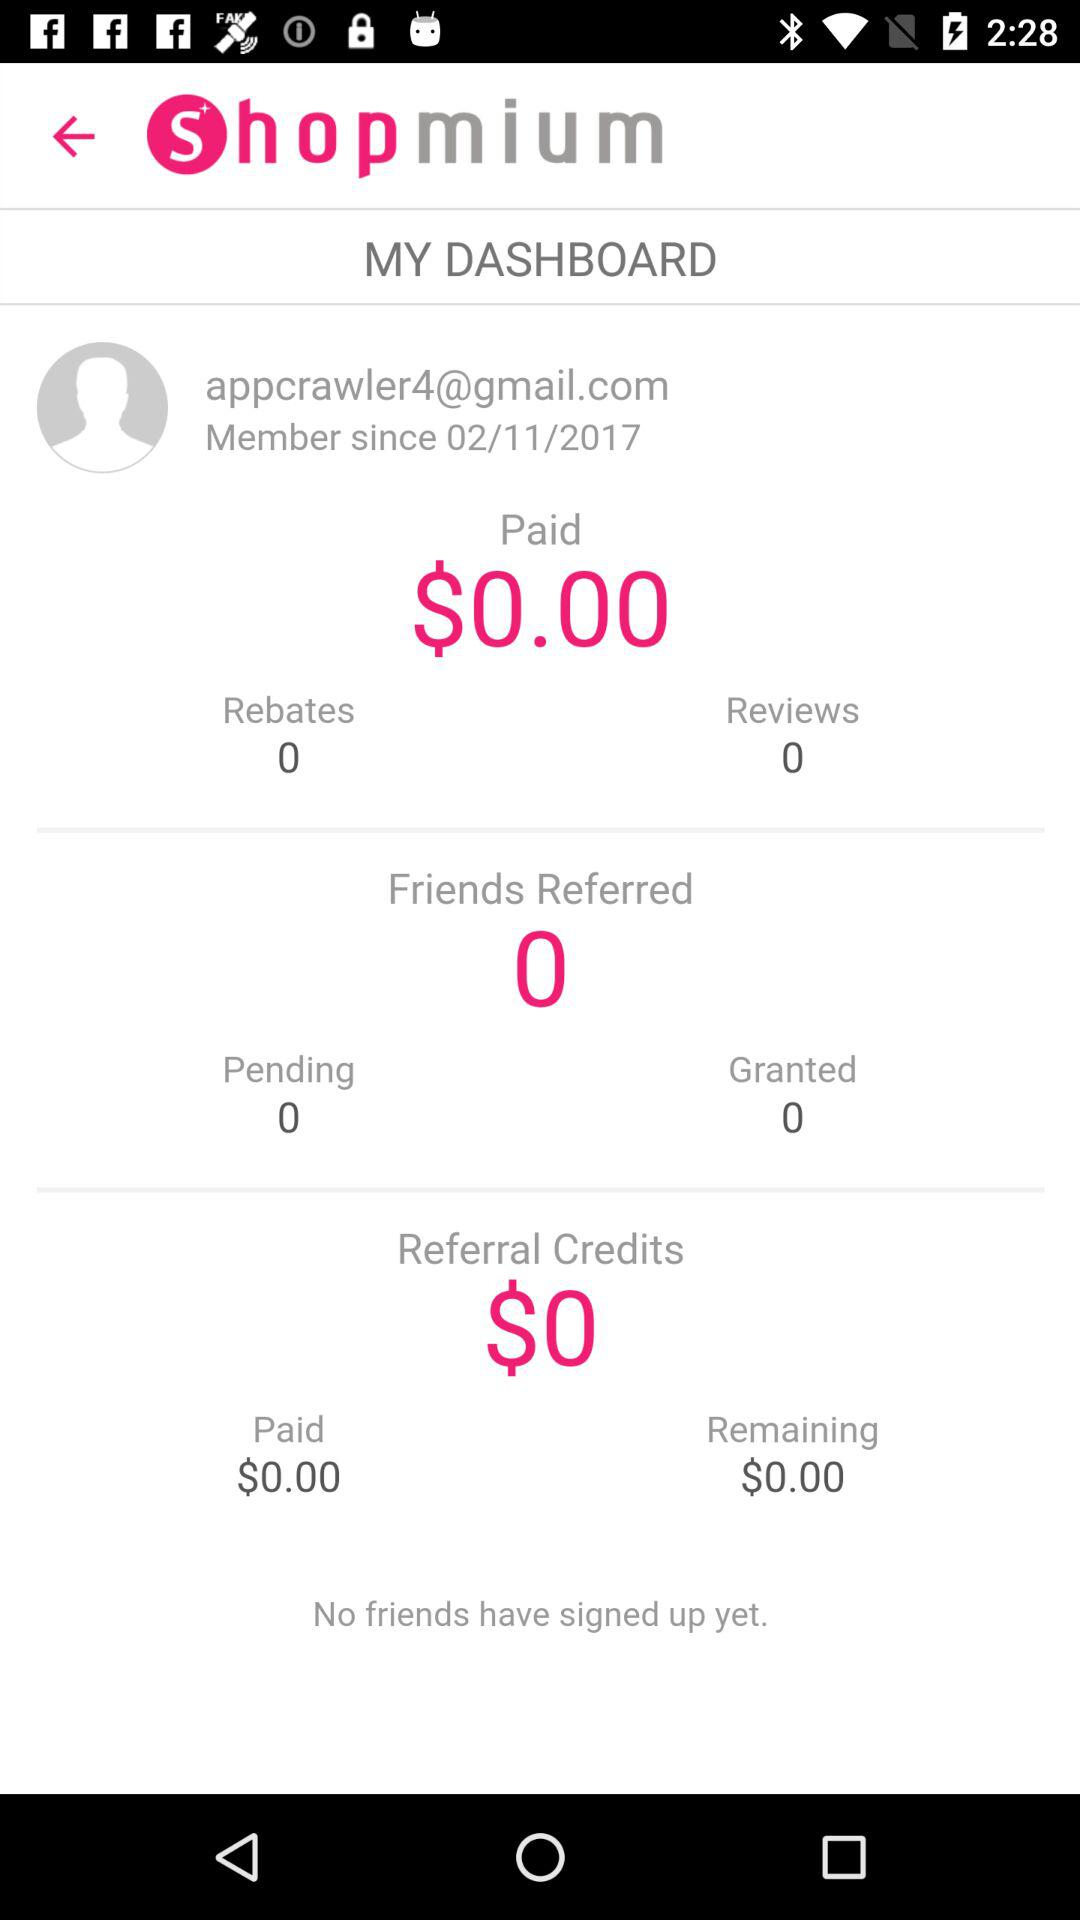How many credits are earned? There are 0 earned credits. 